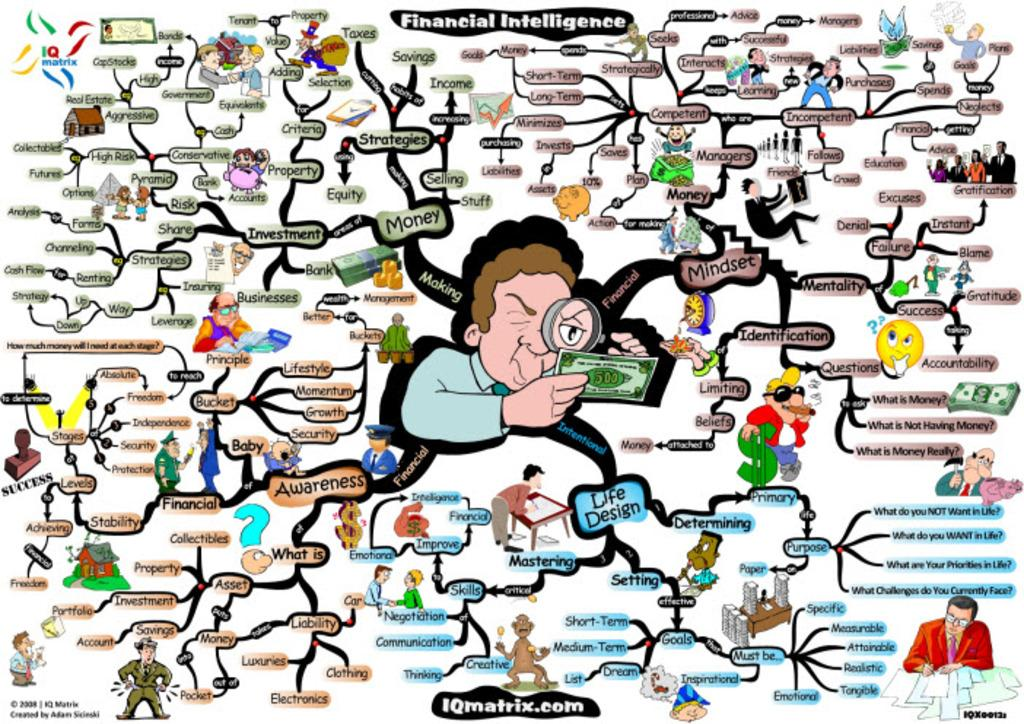What is the main subject of the image? The main subject of the image is a financial intelligence flow chart. What type of images are included in the flow chart? The flow chart contains cartoon images of persons. How are the different steps or stages in the flow chart identified? The flow chart has labels. Can you tell me how many horses are depicted in the flow chart? There are no horses depicted in the flow chart; it features cartoon images of persons and labels related to financial intelligence. 